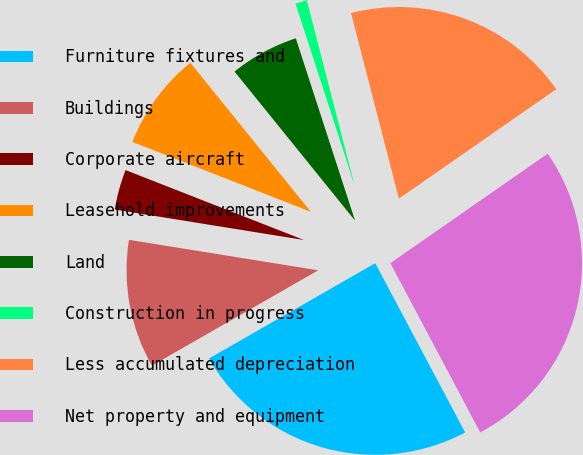Convert chart to OTSL. <chart><loc_0><loc_0><loc_500><loc_500><pie_chart><fcel>Furniture fixtures and<fcel>Buildings<fcel>Corporate aircraft<fcel>Leasehold improvements<fcel>Land<fcel>Construction in progress<fcel>Less accumulated depreciation<fcel>Net property and equipment<nl><fcel>24.49%<fcel>10.83%<fcel>3.4%<fcel>8.24%<fcel>5.82%<fcel>0.98%<fcel>19.35%<fcel>26.91%<nl></chart> 